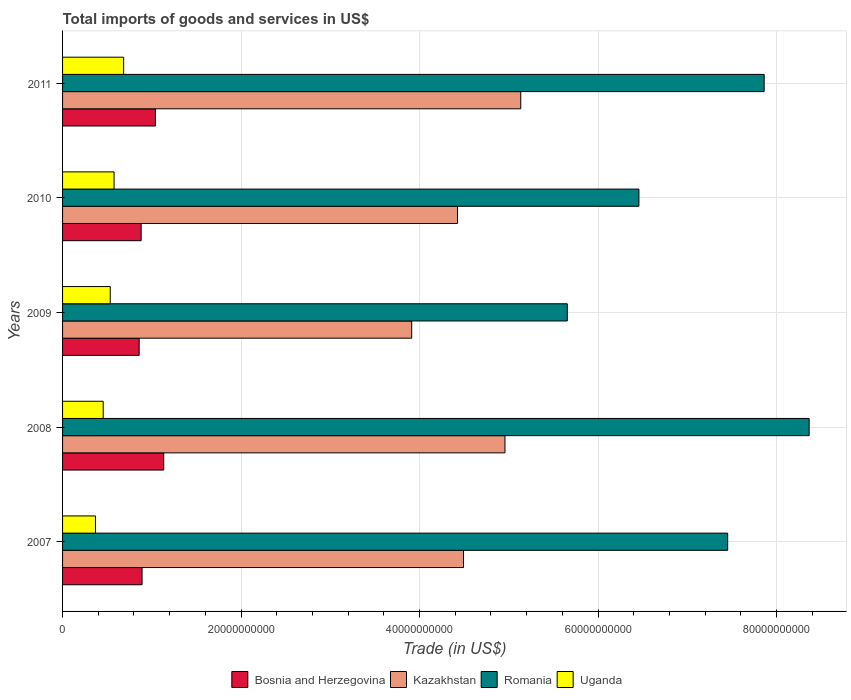How many different coloured bars are there?
Provide a short and direct response. 4. How many groups of bars are there?
Keep it short and to the point. 5. Are the number of bars per tick equal to the number of legend labels?
Offer a terse response. Yes. Are the number of bars on each tick of the Y-axis equal?
Keep it short and to the point. Yes. How many bars are there on the 2nd tick from the bottom?
Your response must be concise. 4. What is the total imports of goods and services in Romania in 2010?
Give a very brief answer. 6.46e+1. Across all years, what is the maximum total imports of goods and services in Kazakhstan?
Your response must be concise. 5.13e+1. Across all years, what is the minimum total imports of goods and services in Uganda?
Your response must be concise. 3.69e+09. What is the total total imports of goods and services in Kazakhstan in the graph?
Provide a succinct answer. 2.29e+11. What is the difference between the total imports of goods and services in Romania in 2008 and that in 2010?
Your response must be concise. 1.91e+1. What is the difference between the total imports of goods and services in Bosnia and Herzegovina in 2010 and the total imports of goods and services in Uganda in 2007?
Your answer should be very brief. 5.11e+09. What is the average total imports of goods and services in Kazakhstan per year?
Provide a succinct answer. 4.58e+1. In the year 2008, what is the difference between the total imports of goods and services in Uganda and total imports of goods and services in Romania?
Provide a short and direct response. -7.91e+1. What is the ratio of the total imports of goods and services in Romania in 2009 to that in 2010?
Provide a succinct answer. 0.88. Is the difference between the total imports of goods and services in Uganda in 2009 and 2011 greater than the difference between the total imports of goods and services in Romania in 2009 and 2011?
Provide a short and direct response. Yes. What is the difference between the highest and the second highest total imports of goods and services in Uganda?
Make the answer very short. 1.07e+09. What is the difference between the highest and the lowest total imports of goods and services in Bosnia and Herzegovina?
Provide a short and direct response. 2.75e+09. In how many years, is the total imports of goods and services in Romania greater than the average total imports of goods and services in Romania taken over all years?
Your answer should be compact. 3. What does the 3rd bar from the top in 2009 represents?
Keep it short and to the point. Kazakhstan. What does the 2nd bar from the bottom in 2010 represents?
Your answer should be very brief. Kazakhstan. Are the values on the major ticks of X-axis written in scientific E-notation?
Give a very brief answer. No. Does the graph contain any zero values?
Make the answer very short. No. Does the graph contain grids?
Provide a short and direct response. Yes. How many legend labels are there?
Give a very brief answer. 4. What is the title of the graph?
Make the answer very short. Total imports of goods and services in US$. What is the label or title of the X-axis?
Keep it short and to the point. Trade (in US$). What is the label or title of the Y-axis?
Keep it short and to the point. Years. What is the Trade (in US$) in Bosnia and Herzegovina in 2007?
Provide a succinct answer. 8.91e+09. What is the Trade (in US$) of Kazakhstan in 2007?
Ensure brevity in your answer.  4.49e+1. What is the Trade (in US$) of Romania in 2007?
Make the answer very short. 7.45e+1. What is the Trade (in US$) of Uganda in 2007?
Offer a terse response. 3.69e+09. What is the Trade (in US$) of Bosnia and Herzegovina in 2008?
Provide a succinct answer. 1.13e+1. What is the Trade (in US$) in Kazakhstan in 2008?
Offer a terse response. 4.96e+1. What is the Trade (in US$) in Romania in 2008?
Make the answer very short. 8.37e+1. What is the Trade (in US$) of Uganda in 2008?
Your answer should be very brief. 4.55e+09. What is the Trade (in US$) of Bosnia and Herzegovina in 2009?
Give a very brief answer. 8.58e+09. What is the Trade (in US$) of Kazakhstan in 2009?
Make the answer very short. 3.91e+1. What is the Trade (in US$) in Romania in 2009?
Provide a succinct answer. 5.66e+1. What is the Trade (in US$) in Uganda in 2009?
Provide a succinct answer. 5.34e+09. What is the Trade (in US$) in Bosnia and Herzegovina in 2010?
Keep it short and to the point. 8.81e+09. What is the Trade (in US$) in Kazakhstan in 2010?
Your response must be concise. 4.43e+1. What is the Trade (in US$) in Romania in 2010?
Provide a short and direct response. 6.46e+1. What is the Trade (in US$) in Uganda in 2010?
Your answer should be compact. 5.77e+09. What is the Trade (in US$) of Bosnia and Herzegovina in 2011?
Provide a short and direct response. 1.04e+1. What is the Trade (in US$) in Kazakhstan in 2011?
Your response must be concise. 5.13e+1. What is the Trade (in US$) of Romania in 2011?
Offer a terse response. 7.86e+1. What is the Trade (in US$) of Uganda in 2011?
Provide a short and direct response. 6.84e+09. Across all years, what is the maximum Trade (in US$) in Bosnia and Herzegovina?
Your answer should be compact. 1.13e+1. Across all years, what is the maximum Trade (in US$) in Kazakhstan?
Make the answer very short. 5.13e+1. Across all years, what is the maximum Trade (in US$) in Romania?
Offer a terse response. 8.37e+1. Across all years, what is the maximum Trade (in US$) in Uganda?
Offer a terse response. 6.84e+09. Across all years, what is the minimum Trade (in US$) in Bosnia and Herzegovina?
Provide a short and direct response. 8.58e+09. Across all years, what is the minimum Trade (in US$) of Kazakhstan?
Offer a very short reply. 3.91e+1. Across all years, what is the minimum Trade (in US$) of Romania?
Your response must be concise. 5.66e+1. Across all years, what is the minimum Trade (in US$) in Uganda?
Provide a succinct answer. 3.69e+09. What is the total Trade (in US$) in Bosnia and Herzegovina in the graph?
Provide a succinct answer. 4.80e+1. What is the total Trade (in US$) of Kazakhstan in the graph?
Keep it short and to the point. 2.29e+11. What is the total Trade (in US$) in Romania in the graph?
Your response must be concise. 3.58e+11. What is the total Trade (in US$) of Uganda in the graph?
Your response must be concise. 2.62e+1. What is the difference between the Trade (in US$) of Bosnia and Herzegovina in 2007 and that in 2008?
Ensure brevity in your answer.  -2.43e+09. What is the difference between the Trade (in US$) in Kazakhstan in 2007 and that in 2008?
Provide a succinct answer. -4.64e+09. What is the difference between the Trade (in US$) in Romania in 2007 and that in 2008?
Offer a terse response. -9.13e+09. What is the difference between the Trade (in US$) of Uganda in 2007 and that in 2008?
Make the answer very short. -8.59e+08. What is the difference between the Trade (in US$) in Bosnia and Herzegovina in 2007 and that in 2009?
Offer a very short reply. 3.23e+08. What is the difference between the Trade (in US$) in Kazakhstan in 2007 and that in 2009?
Make the answer very short. 5.81e+09. What is the difference between the Trade (in US$) in Romania in 2007 and that in 2009?
Give a very brief answer. 1.80e+1. What is the difference between the Trade (in US$) in Uganda in 2007 and that in 2009?
Ensure brevity in your answer.  -1.65e+09. What is the difference between the Trade (in US$) of Bosnia and Herzegovina in 2007 and that in 2010?
Provide a succinct answer. 1.01e+08. What is the difference between the Trade (in US$) of Kazakhstan in 2007 and that in 2010?
Your answer should be compact. 6.70e+08. What is the difference between the Trade (in US$) in Romania in 2007 and that in 2010?
Your answer should be very brief. 9.94e+09. What is the difference between the Trade (in US$) of Uganda in 2007 and that in 2010?
Ensure brevity in your answer.  -2.08e+09. What is the difference between the Trade (in US$) in Bosnia and Herzegovina in 2007 and that in 2011?
Give a very brief answer. -1.50e+09. What is the difference between the Trade (in US$) of Kazakhstan in 2007 and that in 2011?
Your answer should be compact. -6.41e+09. What is the difference between the Trade (in US$) of Romania in 2007 and that in 2011?
Give a very brief answer. -4.09e+09. What is the difference between the Trade (in US$) of Uganda in 2007 and that in 2011?
Ensure brevity in your answer.  -3.15e+09. What is the difference between the Trade (in US$) in Bosnia and Herzegovina in 2008 and that in 2009?
Provide a succinct answer. 2.75e+09. What is the difference between the Trade (in US$) in Kazakhstan in 2008 and that in 2009?
Give a very brief answer. 1.04e+1. What is the difference between the Trade (in US$) of Romania in 2008 and that in 2009?
Make the answer very short. 2.71e+1. What is the difference between the Trade (in US$) of Uganda in 2008 and that in 2009?
Provide a short and direct response. -7.90e+08. What is the difference between the Trade (in US$) in Bosnia and Herzegovina in 2008 and that in 2010?
Make the answer very short. 2.53e+09. What is the difference between the Trade (in US$) in Kazakhstan in 2008 and that in 2010?
Make the answer very short. 5.31e+09. What is the difference between the Trade (in US$) of Romania in 2008 and that in 2010?
Provide a short and direct response. 1.91e+1. What is the difference between the Trade (in US$) of Uganda in 2008 and that in 2010?
Provide a short and direct response. -1.22e+09. What is the difference between the Trade (in US$) in Bosnia and Herzegovina in 2008 and that in 2011?
Make the answer very short. 9.34e+08. What is the difference between the Trade (in US$) in Kazakhstan in 2008 and that in 2011?
Your answer should be very brief. -1.77e+09. What is the difference between the Trade (in US$) of Romania in 2008 and that in 2011?
Ensure brevity in your answer.  5.04e+09. What is the difference between the Trade (in US$) of Uganda in 2008 and that in 2011?
Make the answer very short. -2.29e+09. What is the difference between the Trade (in US$) of Bosnia and Herzegovina in 2009 and that in 2010?
Provide a short and direct response. -2.22e+08. What is the difference between the Trade (in US$) of Kazakhstan in 2009 and that in 2010?
Your answer should be very brief. -5.14e+09. What is the difference between the Trade (in US$) of Romania in 2009 and that in 2010?
Your response must be concise. -8.03e+09. What is the difference between the Trade (in US$) of Uganda in 2009 and that in 2010?
Your answer should be compact. -4.27e+08. What is the difference between the Trade (in US$) of Bosnia and Herzegovina in 2009 and that in 2011?
Provide a succinct answer. -1.82e+09. What is the difference between the Trade (in US$) in Kazakhstan in 2009 and that in 2011?
Provide a short and direct response. -1.22e+1. What is the difference between the Trade (in US$) of Romania in 2009 and that in 2011?
Provide a short and direct response. -2.21e+1. What is the difference between the Trade (in US$) in Uganda in 2009 and that in 2011?
Provide a short and direct response. -1.50e+09. What is the difference between the Trade (in US$) of Bosnia and Herzegovina in 2010 and that in 2011?
Your answer should be very brief. -1.60e+09. What is the difference between the Trade (in US$) of Kazakhstan in 2010 and that in 2011?
Ensure brevity in your answer.  -7.08e+09. What is the difference between the Trade (in US$) in Romania in 2010 and that in 2011?
Your answer should be compact. -1.40e+1. What is the difference between the Trade (in US$) in Uganda in 2010 and that in 2011?
Provide a succinct answer. -1.07e+09. What is the difference between the Trade (in US$) in Bosnia and Herzegovina in 2007 and the Trade (in US$) in Kazakhstan in 2008?
Your response must be concise. -4.07e+1. What is the difference between the Trade (in US$) of Bosnia and Herzegovina in 2007 and the Trade (in US$) of Romania in 2008?
Keep it short and to the point. -7.48e+1. What is the difference between the Trade (in US$) of Bosnia and Herzegovina in 2007 and the Trade (in US$) of Uganda in 2008?
Ensure brevity in your answer.  4.35e+09. What is the difference between the Trade (in US$) in Kazakhstan in 2007 and the Trade (in US$) in Romania in 2008?
Ensure brevity in your answer.  -3.87e+1. What is the difference between the Trade (in US$) of Kazakhstan in 2007 and the Trade (in US$) of Uganda in 2008?
Ensure brevity in your answer.  4.04e+1. What is the difference between the Trade (in US$) of Romania in 2007 and the Trade (in US$) of Uganda in 2008?
Ensure brevity in your answer.  7.00e+1. What is the difference between the Trade (in US$) in Bosnia and Herzegovina in 2007 and the Trade (in US$) in Kazakhstan in 2009?
Provide a succinct answer. -3.02e+1. What is the difference between the Trade (in US$) of Bosnia and Herzegovina in 2007 and the Trade (in US$) of Romania in 2009?
Provide a short and direct response. -4.77e+1. What is the difference between the Trade (in US$) in Bosnia and Herzegovina in 2007 and the Trade (in US$) in Uganda in 2009?
Give a very brief answer. 3.56e+09. What is the difference between the Trade (in US$) of Kazakhstan in 2007 and the Trade (in US$) of Romania in 2009?
Offer a terse response. -1.16e+1. What is the difference between the Trade (in US$) in Kazakhstan in 2007 and the Trade (in US$) in Uganda in 2009?
Provide a succinct answer. 3.96e+1. What is the difference between the Trade (in US$) of Romania in 2007 and the Trade (in US$) of Uganda in 2009?
Your response must be concise. 6.92e+1. What is the difference between the Trade (in US$) of Bosnia and Herzegovina in 2007 and the Trade (in US$) of Kazakhstan in 2010?
Your answer should be very brief. -3.54e+1. What is the difference between the Trade (in US$) in Bosnia and Herzegovina in 2007 and the Trade (in US$) in Romania in 2010?
Give a very brief answer. -5.57e+1. What is the difference between the Trade (in US$) of Bosnia and Herzegovina in 2007 and the Trade (in US$) of Uganda in 2010?
Provide a succinct answer. 3.14e+09. What is the difference between the Trade (in US$) in Kazakhstan in 2007 and the Trade (in US$) in Romania in 2010?
Your answer should be very brief. -1.97e+1. What is the difference between the Trade (in US$) of Kazakhstan in 2007 and the Trade (in US$) of Uganda in 2010?
Provide a succinct answer. 3.92e+1. What is the difference between the Trade (in US$) of Romania in 2007 and the Trade (in US$) of Uganda in 2010?
Your answer should be very brief. 6.88e+1. What is the difference between the Trade (in US$) in Bosnia and Herzegovina in 2007 and the Trade (in US$) in Kazakhstan in 2011?
Provide a succinct answer. -4.24e+1. What is the difference between the Trade (in US$) of Bosnia and Herzegovina in 2007 and the Trade (in US$) of Romania in 2011?
Offer a very short reply. -6.97e+1. What is the difference between the Trade (in US$) in Bosnia and Herzegovina in 2007 and the Trade (in US$) in Uganda in 2011?
Keep it short and to the point. 2.06e+09. What is the difference between the Trade (in US$) in Kazakhstan in 2007 and the Trade (in US$) in Romania in 2011?
Provide a succinct answer. -3.37e+1. What is the difference between the Trade (in US$) of Kazakhstan in 2007 and the Trade (in US$) of Uganda in 2011?
Ensure brevity in your answer.  3.81e+1. What is the difference between the Trade (in US$) of Romania in 2007 and the Trade (in US$) of Uganda in 2011?
Keep it short and to the point. 6.77e+1. What is the difference between the Trade (in US$) of Bosnia and Herzegovina in 2008 and the Trade (in US$) of Kazakhstan in 2009?
Offer a terse response. -2.78e+1. What is the difference between the Trade (in US$) in Bosnia and Herzegovina in 2008 and the Trade (in US$) in Romania in 2009?
Your answer should be very brief. -4.52e+1. What is the difference between the Trade (in US$) in Bosnia and Herzegovina in 2008 and the Trade (in US$) in Uganda in 2009?
Your response must be concise. 5.99e+09. What is the difference between the Trade (in US$) in Kazakhstan in 2008 and the Trade (in US$) in Romania in 2009?
Offer a very short reply. -6.99e+09. What is the difference between the Trade (in US$) of Kazakhstan in 2008 and the Trade (in US$) of Uganda in 2009?
Give a very brief answer. 4.42e+1. What is the difference between the Trade (in US$) of Romania in 2008 and the Trade (in US$) of Uganda in 2009?
Give a very brief answer. 7.83e+1. What is the difference between the Trade (in US$) of Bosnia and Herzegovina in 2008 and the Trade (in US$) of Kazakhstan in 2010?
Your response must be concise. -3.29e+1. What is the difference between the Trade (in US$) of Bosnia and Herzegovina in 2008 and the Trade (in US$) of Romania in 2010?
Provide a succinct answer. -5.32e+1. What is the difference between the Trade (in US$) of Bosnia and Herzegovina in 2008 and the Trade (in US$) of Uganda in 2010?
Your response must be concise. 5.57e+09. What is the difference between the Trade (in US$) of Kazakhstan in 2008 and the Trade (in US$) of Romania in 2010?
Provide a succinct answer. -1.50e+1. What is the difference between the Trade (in US$) of Kazakhstan in 2008 and the Trade (in US$) of Uganda in 2010?
Offer a very short reply. 4.38e+1. What is the difference between the Trade (in US$) of Romania in 2008 and the Trade (in US$) of Uganda in 2010?
Offer a very short reply. 7.79e+1. What is the difference between the Trade (in US$) in Bosnia and Herzegovina in 2008 and the Trade (in US$) in Kazakhstan in 2011?
Your answer should be compact. -4.00e+1. What is the difference between the Trade (in US$) in Bosnia and Herzegovina in 2008 and the Trade (in US$) in Romania in 2011?
Give a very brief answer. -6.73e+1. What is the difference between the Trade (in US$) of Bosnia and Herzegovina in 2008 and the Trade (in US$) of Uganda in 2011?
Make the answer very short. 4.49e+09. What is the difference between the Trade (in US$) in Kazakhstan in 2008 and the Trade (in US$) in Romania in 2011?
Your answer should be compact. -2.90e+1. What is the difference between the Trade (in US$) of Kazakhstan in 2008 and the Trade (in US$) of Uganda in 2011?
Keep it short and to the point. 4.27e+1. What is the difference between the Trade (in US$) of Romania in 2008 and the Trade (in US$) of Uganda in 2011?
Offer a very short reply. 7.68e+1. What is the difference between the Trade (in US$) in Bosnia and Herzegovina in 2009 and the Trade (in US$) in Kazakhstan in 2010?
Your answer should be compact. -3.57e+1. What is the difference between the Trade (in US$) of Bosnia and Herzegovina in 2009 and the Trade (in US$) of Romania in 2010?
Give a very brief answer. -5.60e+1. What is the difference between the Trade (in US$) in Bosnia and Herzegovina in 2009 and the Trade (in US$) in Uganda in 2010?
Keep it short and to the point. 2.81e+09. What is the difference between the Trade (in US$) of Kazakhstan in 2009 and the Trade (in US$) of Romania in 2010?
Your answer should be compact. -2.55e+1. What is the difference between the Trade (in US$) of Kazakhstan in 2009 and the Trade (in US$) of Uganda in 2010?
Your response must be concise. 3.34e+1. What is the difference between the Trade (in US$) of Romania in 2009 and the Trade (in US$) of Uganda in 2010?
Ensure brevity in your answer.  5.08e+1. What is the difference between the Trade (in US$) in Bosnia and Herzegovina in 2009 and the Trade (in US$) in Kazakhstan in 2011?
Your answer should be compact. -4.28e+1. What is the difference between the Trade (in US$) of Bosnia and Herzegovina in 2009 and the Trade (in US$) of Romania in 2011?
Ensure brevity in your answer.  -7.00e+1. What is the difference between the Trade (in US$) in Bosnia and Herzegovina in 2009 and the Trade (in US$) in Uganda in 2011?
Your answer should be very brief. 1.74e+09. What is the difference between the Trade (in US$) in Kazakhstan in 2009 and the Trade (in US$) in Romania in 2011?
Provide a succinct answer. -3.95e+1. What is the difference between the Trade (in US$) of Kazakhstan in 2009 and the Trade (in US$) of Uganda in 2011?
Your answer should be compact. 3.23e+1. What is the difference between the Trade (in US$) of Romania in 2009 and the Trade (in US$) of Uganda in 2011?
Give a very brief answer. 4.97e+1. What is the difference between the Trade (in US$) in Bosnia and Herzegovina in 2010 and the Trade (in US$) in Kazakhstan in 2011?
Make the answer very short. -4.25e+1. What is the difference between the Trade (in US$) in Bosnia and Herzegovina in 2010 and the Trade (in US$) in Romania in 2011?
Provide a short and direct response. -6.98e+1. What is the difference between the Trade (in US$) of Bosnia and Herzegovina in 2010 and the Trade (in US$) of Uganda in 2011?
Keep it short and to the point. 1.96e+09. What is the difference between the Trade (in US$) of Kazakhstan in 2010 and the Trade (in US$) of Romania in 2011?
Your response must be concise. -3.44e+1. What is the difference between the Trade (in US$) in Kazakhstan in 2010 and the Trade (in US$) in Uganda in 2011?
Your answer should be very brief. 3.74e+1. What is the difference between the Trade (in US$) in Romania in 2010 and the Trade (in US$) in Uganda in 2011?
Your response must be concise. 5.77e+1. What is the average Trade (in US$) in Bosnia and Herzegovina per year?
Your response must be concise. 9.61e+09. What is the average Trade (in US$) in Kazakhstan per year?
Your answer should be compact. 4.58e+1. What is the average Trade (in US$) in Romania per year?
Give a very brief answer. 7.16e+1. What is the average Trade (in US$) in Uganda per year?
Offer a terse response. 5.24e+09. In the year 2007, what is the difference between the Trade (in US$) in Bosnia and Herzegovina and Trade (in US$) in Kazakhstan?
Your answer should be very brief. -3.60e+1. In the year 2007, what is the difference between the Trade (in US$) of Bosnia and Herzegovina and Trade (in US$) of Romania?
Your answer should be compact. -6.56e+1. In the year 2007, what is the difference between the Trade (in US$) of Bosnia and Herzegovina and Trade (in US$) of Uganda?
Offer a very short reply. 5.21e+09. In the year 2007, what is the difference between the Trade (in US$) of Kazakhstan and Trade (in US$) of Romania?
Ensure brevity in your answer.  -2.96e+1. In the year 2007, what is the difference between the Trade (in US$) in Kazakhstan and Trade (in US$) in Uganda?
Your answer should be compact. 4.12e+1. In the year 2007, what is the difference between the Trade (in US$) in Romania and Trade (in US$) in Uganda?
Offer a terse response. 7.08e+1. In the year 2008, what is the difference between the Trade (in US$) in Bosnia and Herzegovina and Trade (in US$) in Kazakhstan?
Offer a terse response. -3.82e+1. In the year 2008, what is the difference between the Trade (in US$) in Bosnia and Herzegovina and Trade (in US$) in Romania?
Offer a terse response. -7.23e+1. In the year 2008, what is the difference between the Trade (in US$) in Bosnia and Herzegovina and Trade (in US$) in Uganda?
Ensure brevity in your answer.  6.78e+09. In the year 2008, what is the difference between the Trade (in US$) of Kazakhstan and Trade (in US$) of Romania?
Provide a succinct answer. -3.41e+1. In the year 2008, what is the difference between the Trade (in US$) of Kazakhstan and Trade (in US$) of Uganda?
Give a very brief answer. 4.50e+1. In the year 2008, what is the difference between the Trade (in US$) of Romania and Trade (in US$) of Uganda?
Your answer should be compact. 7.91e+1. In the year 2009, what is the difference between the Trade (in US$) of Bosnia and Herzegovina and Trade (in US$) of Kazakhstan?
Offer a terse response. -3.05e+1. In the year 2009, what is the difference between the Trade (in US$) of Bosnia and Herzegovina and Trade (in US$) of Romania?
Your response must be concise. -4.80e+1. In the year 2009, what is the difference between the Trade (in US$) of Bosnia and Herzegovina and Trade (in US$) of Uganda?
Offer a very short reply. 3.24e+09. In the year 2009, what is the difference between the Trade (in US$) in Kazakhstan and Trade (in US$) in Romania?
Your answer should be very brief. -1.74e+1. In the year 2009, what is the difference between the Trade (in US$) of Kazakhstan and Trade (in US$) of Uganda?
Keep it short and to the point. 3.38e+1. In the year 2009, what is the difference between the Trade (in US$) of Romania and Trade (in US$) of Uganda?
Your answer should be compact. 5.12e+1. In the year 2010, what is the difference between the Trade (in US$) in Bosnia and Herzegovina and Trade (in US$) in Kazakhstan?
Offer a very short reply. -3.55e+1. In the year 2010, what is the difference between the Trade (in US$) in Bosnia and Herzegovina and Trade (in US$) in Romania?
Keep it short and to the point. -5.58e+1. In the year 2010, what is the difference between the Trade (in US$) of Bosnia and Herzegovina and Trade (in US$) of Uganda?
Give a very brief answer. 3.04e+09. In the year 2010, what is the difference between the Trade (in US$) in Kazakhstan and Trade (in US$) in Romania?
Make the answer very short. -2.03e+1. In the year 2010, what is the difference between the Trade (in US$) of Kazakhstan and Trade (in US$) of Uganda?
Your response must be concise. 3.85e+1. In the year 2010, what is the difference between the Trade (in US$) of Romania and Trade (in US$) of Uganda?
Provide a short and direct response. 5.88e+1. In the year 2011, what is the difference between the Trade (in US$) in Bosnia and Herzegovina and Trade (in US$) in Kazakhstan?
Offer a very short reply. -4.09e+1. In the year 2011, what is the difference between the Trade (in US$) in Bosnia and Herzegovina and Trade (in US$) in Romania?
Your response must be concise. -6.82e+1. In the year 2011, what is the difference between the Trade (in US$) of Bosnia and Herzegovina and Trade (in US$) of Uganda?
Your response must be concise. 3.56e+09. In the year 2011, what is the difference between the Trade (in US$) of Kazakhstan and Trade (in US$) of Romania?
Your answer should be compact. -2.73e+1. In the year 2011, what is the difference between the Trade (in US$) of Kazakhstan and Trade (in US$) of Uganda?
Provide a short and direct response. 4.45e+1. In the year 2011, what is the difference between the Trade (in US$) in Romania and Trade (in US$) in Uganda?
Give a very brief answer. 7.18e+1. What is the ratio of the Trade (in US$) of Bosnia and Herzegovina in 2007 to that in 2008?
Make the answer very short. 0.79. What is the ratio of the Trade (in US$) of Kazakhstan in 2007 to that in 2008?
Your response must be concise. 0.91. What is the ratio of the Trade (in US$) in Romania in 2007 to that in 2008?
Your answer should be very brief. 0.89. What is the ratio of the Trade (in US$) of Uganda in 2007 to that in 2008?
Provide a short and direct response. 0.81. What is the ratio of the Trade (in US$) in Bosnia and Herzegovina in 2007 to that in 2009?
Provide a short and direct response. 1.04. What is the ratio of the Trade (in US$) of Kazakhstan in 2007 to that in 2009?
Make the answer very short. 1.15. What is the ratio of the Trade (in US$) in Romania in 2007 to that in 2009?
Give a very brief answer. 1.32. What is the ratio of the Trade (in US$) of Uganda in 2007 to that in 2009?
Provide a short and direct response. 0.69. What is the ratio of the Trade (in US$) of Bosnia and Herzegovina in 2007 to that in 2010?
Provide a short and direct response. 1.01. What is the ratio of the Trade (in US$) of Kazakhstan in 2007 to that in 2010?
Ensure brevity in your answer.  1.02. What is the ratio of the Trade (in US$) in Romania in 2007 to that in 2010?
Offer a very short reply. 1.15. What is the ratio of the Trade (in US$) in Uganda in 2007 to that in 2010?
Keep it short and to the point. 0.64. What is the ratio of the Trade (in US$) in Bosnia and Herzegovina in 2007 to that in 2011?
Make the answer very short. 0.86. What is the ratio of the Trade (in US$) in Kazakhstan in 2007 to that in 2011?
Keep it short and to the point. 0.88. What is the ratio of the Trade (in US$) of Romania in 2007 to that in 2011?
Your response must be concise. 0.95. What is the ratio of the Trade (in US$) of Uganda in 2007 to that in 2011?
Your answer should be very brief. 0.54. What is the ratio of the Trade (in US$) in Bosnia and Herzegovina in 2008 to that in 2009?
Ensure brevity in your answer.  1.32. What is the ratio of the Trade (in US$) in Kazakhstan in 2008 to that in 2009?
Make the answer very short. 1.27. What is the ratio of the Trade (in US$) in Romania in 2008 to that in 2009?
Your response must be concise. 1.48. What is the ratio of the Trade (in US$) in Uganda in 2008 to that in 2009?
Ensure brevity in your answer.  0.85. What is the ratio of the Trade (in US$) in Bosnia and Herzegovina in 2008 to that in 2010?
Your answer should be very brief. 1.29. What is the ratio of the Trade (in US$) of Kazakhstan in 2008 to that in 2010?
Make the answer very short. 1.12. What is the ratio of the Trade (in US$) in Romania in 2008 to that in 2010?
Make the answer very short. 1.3. What is the ratio of the Trade (in US$) of Uganda in 2008 to that in 2010?
Make the answer very short. 0.79. What is the ratio of the Trade (in US$) in Bosnia and Herzegovina in 2008 to that in 2011?
Offer a terse response. 1.09. What is the ratio of the Trade (in US$) of Kazakhstan in 2008 to that in 2011?
Make the answer very short. 0.97. What is the ratio of the Trade (in US$) of Romania in 2008 to that in 2011?
Your answer should be very brief. 1.06. What is the ratio of the Trade (in US$) in Uganda in 2008 to that in 2011?
Offer a terse response. 0.67. What is the ratio of the Trade (in US$) of Bosnia and Herzegovina in 2009 to that in 2010?
Offer a terse response. 0.97. What is the ratio of the Trade (in US$) in Kazakhstan in 2009 to that in 2010?
Make the answer very short. 0.88. What is the ratio of the Trade (in US$) of Romania in 2009 to that in 2010?
Offer a very short reply. 0.88. What is the ratio of the Trade (in US$) in Uganda in 2009 to that in 2010?
Your response must be concise. 0.93. What is the ratio of the Trade (in US$) of Bosnia and Herzegovina in 2009 to that in 2011?
Make the answer very short. 0.83. What is the ratio of the Trade (in US$) in Kazakhstan in 2009 to that in 2011?
Give a very brief answer. 0.76. What is the ratio of the Trade (in US$) in Romania in 2009 to that in 2011?
Provide a succinct answer. 0.72. What is the ratio of the Trade (in US$) in Uganda in 2009 to that in 2011?
Give a very brief answer. 0.78. What is the ratio of the Trade (in US$) in Bosnia and Herzegovina in 2010 to that in 2011?
Provide a succinct answer. 0.85. What is the ratio of the Trade (in US$) in Kazakhstan in 2010 to that in 2011?
Offer a very short reply. 0.86. What is the ratio of the Trade (in US$) in Romania in 2010 to that in 2011?
Offer a very short reply. 0.82. What is the ratio of the Trade (in US$) of Uganda in 2010 to that in 2011?
Offer a very short reply. 0.84. What is the difference between the highest and the second highest Trade (in US$) in Bosnia and Herzegovina?
Keep it short and to the point. 9.34e+08. What is the difference between the highest and the second highest Trade (in US$) of Kazakhstan?
Ensure brevity in your answer.  1.77e+09. What is the difference between the highest and the second highest Trade (in US$) of Romania?
Provide a succinct answer. 5.04e+09. What is the difference between the highest and the second highest Trade (in US$) in Uganda?
Make the answer very short. 1.07e+09. What is the difference between the highest and the lowest Trade (in US$) of Bosnia and Herzegovina?
Your answer should be very brief. 2.75e+09. What is the difference between the highest and the lowest Trade (in US$) of Kazakhstan?
Your answer should be compact. 1.22e+1. What is the difference between the highest and the lowest Trade (in US$) of Romania?
Give a very brief answer. 2.71e+1. What is the difference between the highest and the lowest Trade (in US$) of Uganda?
Provide a short and direct response. 3.15e+09. 